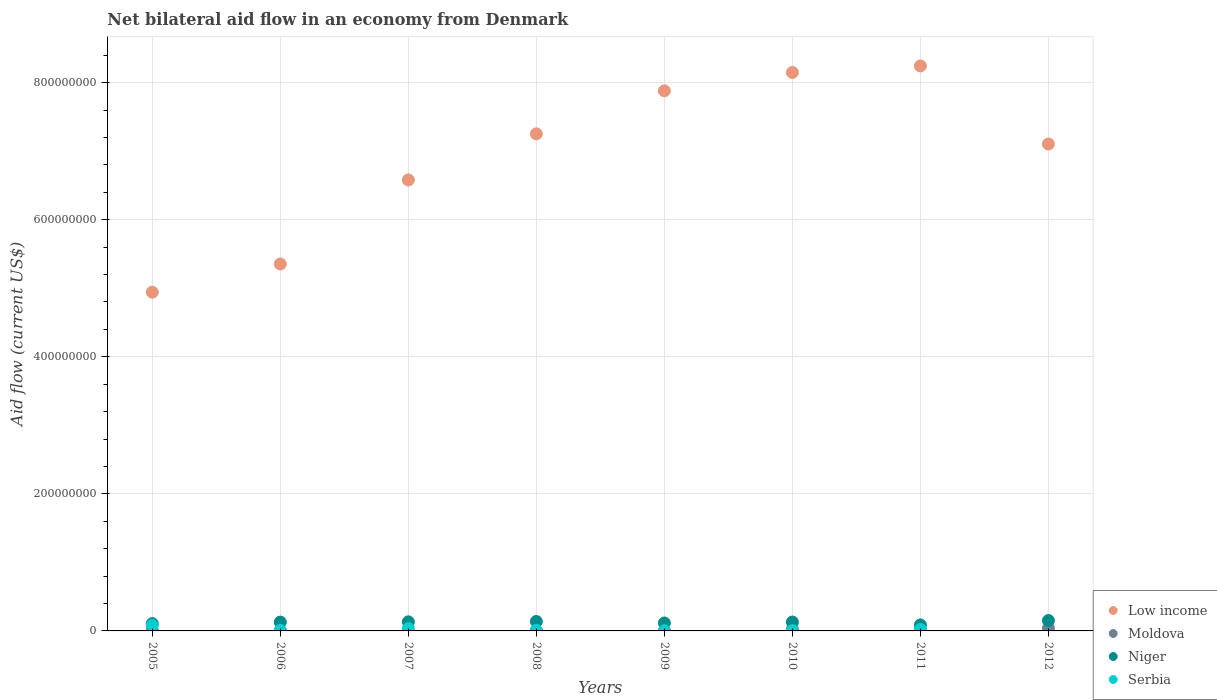How many different coloured dotlines are there?
Ensure brevity in your answer.  4. Is the number of dotlines equal to the number of legend labels?
Keep it short and to the point. No. What is the net bilateral aid flow in Niger in 2006?
Offer a very short reply. 1.29e+07. Across all years, what is the maximum net bilateral aid flow in Niger?
Ensure brevity in your answer.  1.52e+07. Across all years, what is the minimum net bilateral aid flow in Niger?
Make the answer very short. 8.79e+06. What is the total net bilateral aid flow in Niger in the graph?
Give a very brief answer. 9.91e+07. What is the difference between the net bilateral aid flow in Serbia in 2007 and that in 2011?
Make the answer very short. 1.16e+06. What is the difference between the net bilateral aid flow in Serbia in 2006 and the net bilateral aid flow in Niger in 2011?
Your response must be concise. -7.94e+06. What is the average net bilateral aid flow in Niger per year?
Give a very brief answer. 1.24e+07. In the year 2010, what is the difference between the net bilateral aid flow in Niger and net bilateral aid flow in Moldova?
Offer a very short reply. 1.03e+07. What is the ratio of the net bilateral aid flow in Serbia in 2007 to that in 2008?
Your answer should be compact. 3.74. Is the net bilateral aid flow in Low income in 2008 less than that in 2010?
Your response must be concise. Yes. What is the difference between the highest and the second highest net bilateral aid flow in Moldova?
Your response must be concise. 1.28e+06. What is the difference between the highest and the lowest net bilateral aid flow in Serbia?
Offer a terse response. 8.02e+06. In how many years, is the net bilateral aid flow in Serbia greater than the average net bilateral aid flow in Serbia taken over all years?
Make the answer very short. 3. Is the sum of the net bilateral aid flow in Serbia in 2008 and 2011 greater than the maximum net bilateral aid flow in Moldova across all years?
Ensure brevity in your answer.  No. Is it the case that in every year, the sum of the net bilateral aid flow in Moldova and net bilateral aid flow in Serbia  is greater than the net bilateral aid flow in Low income?
Your answer should be compact. No. Does the net bilateral aid flow in Niger monotonically increase over the years?
Your answer should be very brief. No. Is the net bilateral aid flow in Moldova strictly greater than the net bilateral aid flow in Serbia over the years?
Your answer should be compact. No. Is the net bilateral aid flow in Moldova strictly less than the net bilateral aid flow in Low income over the years?
Offer a terse response. Yes. How many years are there in the graph?
Offer a terse response. 8. What is the difference between two consecutive major ticks on the Y-axis?
Your response must be concise. 2.00e+08. Are the values on the major ticks of Y-axis written in scientific E-notation?
Offer a very short reply. No. Does the graph contain any zero values?
Provide a succinct answer. Yes. Where does the legend appear in the graph?
Ensure brevity in your answer.  Bottom right. What is the title of the graph?
Provide a short and direct response. Net bilateral aid flow in an economy from Denmark. What is the label or title of the Y-axis?
Make the answer very short. Aid flow (current US$). What is the Aid flow (current US$) of Low income in 2005?
Keep it short and to the point. 4.94e+08. What is the Aid flow (current US$) in Moldova in 2005?
Offer a very short reply. 9.00e+05. What is the Aid flow (current US$) of Niger in 2005?
Your response must be concise. 1.07e+07. What is the Aid flow (current US$) in Serbia in 2005?
Keep it short and to the point. 8.02e+06. What is the Aid flow (current US$) in Low income in 2006?
Ensure brevity in your answer.  5.35e+08. What is the Aid flow (current US$) in Niger in 2006?
Ensure brevity in your answer.  1.29e+07. What is the Aid flow (current US$) in Serbia in 2006?
Your response must be concise. 8.50e+05. What is the Aid flow (current US$) in Low income in 2007?
Make the answer very short. 6.58e+08. What is the Aid flow (current US$) of Moldova in 2007?
Offer a very short reply. 8.00e+04. What is the Aid flow (current US$) of Niger in 2007?
Your answer should be very brief. 1.33e+07. What is the Aid flow (current US$) of Serbia in 2007?
Your response must be concise. 3.40e+06. What is the Aid flow (current US$) in Low income in 2008?
Provide a short and direct response. 7.25e+08. What is the Aid flow (current US$) of Moldova in 2008?
Make the answer very short. 2.10e+05. What is the Aid flow (current US$) of Niger in 2008?
Keep it short and to the point. 1.38e+07. What is the Aid flow (current US$) in Serbia in 2008?
Offer a terse response. 9.10e+05. What is the Aid flow (current US$) in Low income in 2009?
Make the answer very short. 7.88e+08. What is the Aid flow (current US$) in Moldova in 2009?
Offer a very short reply. 3.40e+05. What is the Aid flow (current US$) in Niger in 2009?
Make the answer very short. 1.16e+07. What is the Aid flow (current US$) of Low income in 2010?
Keep it short and to the point. 8.15e+08. What is the Aid flow (current US$) of Moldova in 2010?
Ensure brevity in your answer.  2.69e+06. What is the Aid flow (current US$) in Niger in 2010?
Give a very brief answer. 1.30e+07. What is the Aid flow (current US$) of Low income in 2011?
Make the answer very short. 8.24e+08. What is the Aid flow (current US$) in Moldova in 2011?
Keep it short and to the point. 1.80e+06. What is the Aid flow (current US$) of Niger in 2011?
Provide a short and direct response. 8.79e+06. What is the Aid flow (current US$) of Serbia in 2011?
Keep it short and to the point. 2.24e+06. What is the Aid flow (current US$) of Low income in 2012?
Keep it short and to the point. 7.11e+08. What is the Aid flow (current US$) of Moldova in 2012?
Provide a short and direct response. 3.97e+06. What is the Aid flow (current US$) of Niger in 2012?
Offer a terse response. 1.52e+07. Across all years, what is the maximum Aid flow (current US$) in Low income?
Your response must be concise. 8.24e+08. Across all years, what is the maximum Aid flow (current US$) in Moldova?
Provide a short and direct response. 3.97e+06. Across all years, what is the maximum Aid flow (current US$) of Niger?
Make the answer very short. 1.52e+07. Across all years, what is the maximum Aid flow (current US$) in Serbia?
Your answer should be compact. 8.02e+06. Across all years, what is the minimum Aid flow (current US$) in Low income?
Provide a succinct answer. 4.94e+08. Across all years, what is the minimum Aid flow (current US$) of Niger?
Your response must be concise. 8.79e+06. Across all years, what is the minimum Aid flow (current US$) of Serbia?
Your answer should be very brief. 0. What is the total Aid flow (current US$) of Low income in the graph?
Make the answer very short. 5.55e+09. What is the total Aid flow (current US$) of Moldova in the graph?
Make the answer very short. 1.04e+07. What is the total Aid flow (current US$) of Niger in the graph?
Your answer should be very brief. 9.91e+07. What is the total Aid flow (current US$) in Serbia in the graph?
Give a very brief answer. 1.61e+07. What is the difference between the Aid flow (current US$) in Low income in 2005 and that in 2006?
Offer a very short reply. -4.12e+07. What is the difference between the Aid flow (current US$) in Moldova in 2005 and that in 2006?
Your answer should be compact. 4.90e+05. What is the difference between the Aid flow (current US$) of Niger in 2005 and that in 2006?
Give a very brief answer. -2.19e+06. What is the difference between the Aid flow (current US$) in Serbia in 2005 and that in 2006?
Give a very brief answer. 7.17e+06. What is the difference between the Aid flow (current US$) of Low income in 2005 and that in 2007?
Offer a very short reply. -1.64e+08. What is the difference between the Aid flow (current US$) in Moldova in 2005 and that in 2007?
Provide a succinct answer. 8.20e+05. What is the difference between the Aid flow (current US$) in Niger in 2005 and that in 2007?
Offer a very short reply. -2.59e+06. What is the difference between the Aid flow (current US$) of Serbia in 2005 and that in 2007?
Provide a succinct answer. 4.62e+06. What is the difference between the Aid flow (current US$) of Low income in 2005 and that in 2008?
Provide a short and direct response. -2.31e+08. What is the difference between the Aid flow (current US$) in Moldova in 2005 and that in 2008?
Make the answer very short. 6.90e+05. What is the difference between the Aid flow (current US$) in Niger in 2005 and that in 2008?
Offer a terse response. -3.12e+06. What is the difference between the Aid flow (current US$) of Serbia in 2005 and that in 2008?
Ensure brevity in your answer.  7.11e+06. What is the difference between the Aid flow (current US$) of Low income in 2005 and that in 2009?
Ensure brevity in your answer.  -2.94e+08. What is the difference between the Aid flow (current US$) in Moldova in 2005 and that in 2009?
Provide a short and direct response. 5.60e+05. What is the difference between the Aid flow (current US$) in Niger in 2005 and that in 2009?
Offer a terse response. -9.20e+05. What is the difference between the Aid flow (current US$) in Serbia in 2005 and that in 2009?
Your response must be concise. 7.71e+06. What is the difference between the Aid flow (current US$) of Low income in 2005 and that in 2010?
Give a very brief answer. -3.21e+08. What is the difference between the Aid flow (current US$) of Moldova in 2005 and that in 2010?
Your response must be concise. -1.79e+06. What is the difference between the Aid flow (current US$) of Niger in 2005 and that in 2010?
Provide a succinct answer. -2.29e+06. What is the difference between the Aid flow (current US$) in Serbia in 2005 and that in 2010?
Make the answer very short. 7.65e+06. What is the difference between the Aid flow (current US$) of Low income in 2005 and that in 2011?
Keep it short and to the point. -3.30e+08. What is the difference between the Aid flow (current US$) of Moldova in 2005 and that in 2011?
Keep it short and to the point. -9.00e+05. What is the difference between the Aid flow (current US$) of Niger in 2005 and that in 2011?
Your answer should be compact. 1.88e+06. What is the difference between the Aid flow (current US$) in Serbia in 2005 and that in 2011?
Your answer should be very brief. 5.78e+06. What is the difference between the Aid flow (current US$) of Low income in 2005 and that in 2012?
Your answer should be compact. -2.16e+08. What is the difference between the Aid flow (current US$) of Moldova in 2005 and that in 2012?
Give a very brief answer. -3.07e+06. What is the difference between the Aid flow (current US$) of Niger in 2005 and that in 2012?
Keep it short and to the point. -4.51e+06. What is the difference between the Aid flow (current US$) of Low income in 2006 and that in 2007?
Give a very brief answer. -1.23e+08. What is the difference between the Aid flow (current US$) of Niger in 2006 and that in 2007?
Ensure brevity in your answer.  -4.00e+05. What is the difference between the Aid flow (current US$) of Serbia in 2006 and that in 2007?
Offer a very short reply. -2.55e+06. What is the difference between the Aid flow (current US$) of Low income in 2006 and that in 2008?
Offer a very short reply. -1.90e+08. What is the difference between the Aid flow (current US$) of Moldova in 2006 and that in 2008?
Your answer should be very brief. 2.00e+05. What is the difference between the Aid flow (current US$) in Niger in 2006 and that in 2008?
Provide a succinct answer. -9.30e+05. What is the difference between the Aid flow (current US$) in Serbia in 2006 and that in 2008?
Ensure brevity in your answer.  -6.00e+04. What is the difference between the Aid flow (current US$) in Low income in 2006 and that in 2009?
Provide a succinct answer. -2.53e+08. What is the difference between the Aid flow (current US$) in Moldova in 2006 and that in 2009?
Provide a succinct answer. 7.00e+04. What is the difference between the Aid flow (current US$) of Niger in 2006 and that in 2009?
Provide a succinct answer. 1.27e+06. What is the difference between the Aid flow (current US$) in Serbia in 2006 and that in 2009?
Your answer should be compact. 5.40e+05. What is the difference between the Aid flow (current US$) in Low income in 2006 and that in 2010?
Keep it short and to the point. -2.80e+08. What is the difference between the Aid flow (current US$) in Moldova in 2006 and that in 2010?
Give a very brief answer. -2.28e+06. What is the difference between the Aid flow (current US$) in Serbia in 2006 and that in 2010?
Your answer should be compact. 4.80e+05. What is the difference between the Aid flow (current US$) of Low income in 2006 and that in 2011?
Offer a very short reply. -2.89e+08. What is the difference between the Aid flow (current US$) of Moldova in 2006 and that in 2011?
Keep it short and to the point. -1.39e+06. What is the difference between the Aid flow (current US$) in Niger in 2006 and that in 2011?
Make the answer very short. 4.07e+06. What is the difference between the Aid flow (current US$) of Serbia in 2006 and that in 2011?
Offer a terse response. -1.39e+06. What is the difference between the Aid flow (current US$) of Low income in 2006 and that in 2012?
Provide a short and direct response. -1.75e+08. What is the difference between the Aid flow (current US$) of Moldova in 2006 and that in 2012?
Offer a very short reply. -3.56e+06. What is the difference between the Aid flow (current US$) in Niger in 2006 and that in 2012?
Keep it short and to the point. -2.32e+06. What is the difference between the Aid flow (current US$) of Low income in 2007 and that in 2008?
Offer a terse response. -6.72e+07. What is the difference between the Aid flow (current US$) of Niger in 2007 and that in 2008?
Give a very brief answer. -5.30e+05. What is the difference between the Aid flow (current US$) in Serbia in 2007 and that in 2008?
Give a very brief answer. 2.49e+06. What is the difference between the Aid flow (current US$) of Low income in 2007 and that in 2009?
Ensure brevity in your answer.  -1.30e+08. What is the difference between the Aid flow (current US$) of Moldova in 2007 and that in 2009?
Give a very brief answer. -2.60e+05. What is the difference between the Aid flow (current US$) in Niger in 2007 and that in 2009?
Keep it short and to the point. 1.67e+06. What is the difference between the Aid flow (current US$) in Serbia in 2007 and that in 2009?
Provide a succinct answer. 3.09e+06. What is the difference between the Aid flow (current US$) of Low income in 2007 and that in 2010?
Your answer should be very brief. -1.57e+08. What is the difference between the Aid flow (current US$) of Moldova in 2007 and that in 2010?
Keep it short and to the point. -2.61e+06. What is the difference between the Aid flow (current US$) in Niger in 2007 and that in 2010?
Your answer should be very brief. 3.00e+05. What is the difference between the Aid flow (current US$) in Serbia in 2007 and that in 2010?
Offer a very short reply. 3.03e+06. What is the difference between the Aid flow (current US$) of Low income in 2007 and that in 2011?
Your answer should be compact. -1.66e+08. What is the difference between the Aid flow (current US$) of Moldova in 2007 and that in 2011?
Ensure brevity in your answer.  -1.72e+06. What is the difference between the Aid flow (current US$) of Niger in 2007 and that in 2011?
Give a very brief answer. 4.47e+06. What is the difference between the Aid flow (current US$) in Serbia in 2007 and that in 2011?
Your answer should be very brief. 1.16e+06. What is the difference between the Aid flow (current US$) in Low income in 2007 and that in 2012?
Your answer should be very brief. -5.24e+07. What is the difference between the Aid flow (current US$) of Moldova in 2007 and that in 2012?
Ensure brevity in your answer.  -3.89e+06. What is the difference between the Aid flow (current US$) in Niger in 2007 and that in 2012?
Give a very brief answer. -1.92e+06. What is the difference between the Aid flow (current US$) of Low income in 2008 and that in 2009?
Give a very brief answer. -6.28e+07. What is the difference between the Aid flow (current US$) in Niger in 2008 and that in 2009?
Give a very brief answer. 2.20e+06. What is the difference between the Aid flow (current US$) in Serbia in 2008 and that in 2009?
Give a very brief answer. 6.00e+05. What is the difference between the Aid flow (current US$) of Low income in 2008 and that in 2010?
Your answer should be compact. -8.96e+07. What is the difference between the Aid flow (current US$) of Moldova in 2008 and that in 2010?
Offer a very short reply. -2.48e+06. What is the difference between the Aid flow (current US$) of Niger in 2008 and that in 2010?
Offer a very short reply. 8.30e+05. What is the difference between the Aid flow (current US$) in Serbia in 2008 and that in 2010?
Offer a terse response. 5.40e+05. What is the difference between the Aid flow (current US$) in Low income in 2008 and that in 2011?
Your answer should be compact. -9.91e+07. What is the difference between the Aid flow (current US$) in Moldova in 2008 and that in 2011?
Keep it short and to the point. -1.59e+06. What is the difference between the Aid flow (current US$) in Niger in 2008 and that in 2011?
Make the answer very short. 5.00e+06. What is the difference between the Aid flow (current US$) of Serbia in 2008 and that in 2011?
Offer a terse response. -1.33e+06. What is the difference between the Aid flow (current US$) in Low income in 2008 and that in 2012?
Provide a short and direct response. 1.49e+07. What is the difference between the Aid flow (current US$) of Moldova in 2008 and that in 2012?
Your response must be concise. -3.76e+06. What is the difference between the Aid flow (current US$) in Niger in 2008 and that in 2012?
Provide a succinct answer. -1.39e+06. What is the difference between the Aid flow (current US$) of Low income in 2009 and that in 2010?
Ensure brevity in your answer.  -2.68e+07. What is the difference between the Aid flow (current US$) of Moldova in 2009 and that in 2010?
Make the answer very short. -2.35e+06. What is the difference between the Aid flow (current US$) in Niger in 2009 and that in 2010?
Your response must be concise. -1.37e+06. What is the difference between the Aid flow (current US$) of Low income in 2009 and that in 2011?
Offer a very short reply. -3.63e+07. What is the difference between the Aid flow (current US$) of Moldova in 2009 and that in 2011?
Give a very brief answer. -1.46e+06. What is the difference between the Aid flow (current US$) of Niger in 2009 and that in 2011?
Provide a succinct answer. 2.80e+06. What is the difference between the Aid flow (current US$) in Serbia in 2009 and that in 2011?
Keep it short and to the point. -1.93e+06. What is the difference between the Aid flow (current US$) of Low income in 2009 and that in 2012?
Make the answer very short. 7.77e+07. What is the difference between the Aid flow (current US$) in Moldova in 2009 and that in 2012?
Your answer should be very brief. -3.63e+06. What is the difference between the Aid flow (current US$) of Niger in 2009 and that in 2012?
Keep it short and to the point. -3.59e+06. What is the difference between the Aid flow (current US$) of Low income in 2010 and that in 2011?
Ensure brevity in your answer.  -9.54e+06. What is the difference between the Aid flow (current US$) of Moldova in 2010 and that in 2011?
Your answer should be compact. 8.90e+05. What is the difference between the Aid flow (current US$) in Niger in 2010 and that in 2011?
Ensure brevity in your answer.  4.17e+06. What is the difference between the Aid flow (current US$) in Serbia in 2010 and that in 2011?
Make the answer very short. -1.87e+06. What is the difference between the Aid flow (current US$) of Low income in 2010 and that in 2012?
Make the answer very short. 1.04e+08. What is the difference between the Aid flow (current US$) of Moldova in 2010 and that in 2012?
Your answer should be compact. -1.28e+06. What is the difference between the Aid flow (current US$) in Niger in 2010 and that in 2012?
Offer a very short reply. -2.22e+06. What is the difference between the Aid flow (current US$) in Low income in 2011 and that in 2012?
Provide a succinct answer. 1.14e+08. What is the difference between the Aid flow (current US$) of Moldova in 2011 and that in 2012?
Offer a very short reply. -2.17e+06. What is the difference between the Aid flow (current US$) in Niger in 2011 and that in 2012?
Your answer should be compact. -6.39e+06. What is the difference between the Aid flow (current US$) of Low income in 2005 and the Aid flow (current US$) of Moldova in 2006?
Make the answer very short. 4.94e+08. What is the difference between the Aid flow (current US$) of Low income in 2005 and the Aid flow (current US$) of Niger in 2006?
Ensure brevity in your answer.  4.81e+08. What is the difference between the Aid flow (current US$) in Low income in 2005 and the Aid flow (current US$) in Serbia in 2006?
Offer a terse response. 4.93e+08. What is the difference between the Aid flow (current US$) of Moldova in 2005 and the Aid flow (current US$) of Niger in 2006?
Keep it short and to the point. -1.20e+07. What is the difference between the Aid flow (current US$) of Moldova in 2005 and the Aid flow (current US$) of Serbia in 2006?
Keep it short and to the point. 5.00e+04. What is the difference between the Aid flow (current US$) in Niger in 2005 and the Aid flow (current US$) in Serbia in 2006?
Your answer should be compact. 9.82e+06. What is the difference between the Aid flow (current US$) of Low income in 2005 and the Aid flow (current US$) of Moldova in 2007?
Offer a very short reply. 4.94e+08. What is the difference between the Aid flow (current US$) of Low income in 2005 and the Aid flow (current US$) of Niger in 2007?
Provide a succinct answer. 4.81e+08. What is the difference between the Aid flow (current US$) in Low income in 2005 and the Aid flow (current US$) in Serbia in 2007?
Your answer should be compact. 4.91e+08. What is the difference between the Aid flow (current US$) of Moldova in 2005 and the Aid flow (current US$) of Niger in 2007?
Your answer should be compact. -1.24e+07. What is the difference between the Aid flow (current US$) in Moldova in 2005 and the Aid flow (current US$) in Serbia in 2007?
Provide a short and direct response. -2.50e+06. What is the difference between the Aid flow (current US$) of Niger in 2005 and the Aid flow (current US$) of Serbia in 2007?
Your response must be concise. 7.27e+06. What is the difference between the Aid flow (current US$) in Low income in 2005 and the Aid flow (current US$) in Moldova in 2008?
Provide a succinct answer. 4.94e+08. What is the difference between the Aid flow (current US$) in Low income in 2005 and the Aid flow (current US$) in Niger in 2008?
Make the answer very short. 4.80e+08. What is the difference between the Aid flow (current US$) of Low income in 2005 and the Aid flow (current US$) of Serbia in 2008?
Make the answer very short. 4.93e+08. What is the difference between the Aid flow (current US$) in Moldova in 2005 and the Aid flow (current US$) in Niger in 2008?
Your answer should be compact. -1.29e+07. What is the difference between the Aid flow (current US$) in Moldova in 2005 and the Aid flow (current US$) in Serbia in 2008?
Keep it short and to the point. -10000. What is the difference between the Aid flow (current US$) in Niger in 2005 and the Aid flow (current US$) in Serbia in 2008?
Your answer should be compact. 9.76e+06. What is the difference between the Aid flow (current US$) in Low income in 2005 and the Aid flow (current US$) in Moldova in 2009?
Your answer should be very brief. 4.94e+08. What is the difference between the Aid flow (current US$) in Low income in 2005 and the Aid flow (current US$) in Niger in 2009?
Your answer should be very brief. 4.83e+08. What is the difference between the Aid flow (current US$) in Low income in 2005 and the Aid flow (current US$) in Serbia in 2009?
Provide a succinct answer. 4.94e+08. What is the difference between the Aid flow (current US$) in Moldova in 2005 and the Aid flow (current US$) in Niger in 2009?
Provide a succinct answer. -1.07e+07. What is the difference between the Aid flow (current US$) of Moldova in 2005 and the Aid flow (current US$) of Serbia in 2009?
Keep it short and to the point. 5.90e+05. What is the difference between the Aid flow (current US$) of Niger in 2005 and the Aid flow (current US$) of Serbia in 2009?
Give a very brief answer. 1.04e+07. What is the difference between the Aid flow (current US$) in Low income in 2005 and the Aid flow (current US$) in Moldova in 2010?
Your response must be concise. 4.92e+08. What is the difference between the Aid flow (current US$) of Low income in 2005 and the Aid flow (current US$) of Niger in 2010?
Keep it short and to the point. 4.81e+08. What is the difference between the Aid flow (current US$) in Low income in 2005 and the Aid flow (current US$) in Serbia in 2010?
Your answer should be very brief. 4.94e+08. What is the difference between the Aid flow (current US$) of Moldova in 2005 and the Aid flow (current US$) of Niger in 2010?
Offer a terse response. -1.21e+07. What is the difference between the Aid flow (current US$) in Moldova in 2005 and the Aid flow (current US$) in Serbia in 2010?
Give a very brief answer. 5.30e+05. What is the difference between the Aid flow (current US$) in Niger in 2005 and the Aid flow (current US$) in Serbia in 2010?
Your response must be concise. 1.03e+07. What is the difference between the Aid flow (current US$) of Low income in 2005 and the Aid flow (current US$) of Moldova in 2011?
Offer a very short reply. 4.92e+08. What is the difference between the Aid flow (current US$) in Low income in 2005 and the Aid flow (current US$) in Niger in 2011?
Offer a very short reply. 4.86e+08. What is the difference between the Aid flow (current US$) in Low income in 2005 and the Aid flow (current US$) in Serbia in 2011?
Your answer should be compact. 4.92e+08. What is the difference between the Aid flow (current US$) in Moldova in 2005 and the Aid flow (current US$) in Niger in 2011?
Offer a terse response. -7.89e+06. What is the difference between the Aid flow (current US$) in Moldova in 2005 and the Aid flow (current US$) in Serbia in 2011?
Your answer should be compact. -1.34e+06. What is the difference between the Aid flow (current US$) in Niger in 2005 and the Aid flow (current US$) in Serbia in 2011?
Provide a short and direct response. 8.43e+06. What is the difference between the Aid flow (current US$) in Low income in 2005 and the Aid flow (current US$) in Moldova in 2012?
Your response must be concise. 4.90e+08. What is the difference between the Aid flow (current US$) of Low income in 2005 and the Aid flow (current US$) of Niger in 2012?
Provide a short and direct response. 4.79e+08. What is the difference between the Aid flow (current US$) of Moldova in 2005 and the Aid flow (current US$) of Niger in 2012?
Your answer should be very brief. -1.43e+07. What is the difference between the Aid flow (current US$) of Low income in 2006 and the Aid flow (current US$) of Moldova in 2007?
Your answer should be very brief. 5.35e+08. What is the difference between the Aid flow (current US$) of Low income in 2006 and the Aid flow (current US$) of Niger in 2007?
Your response must be concise. 5.22e+08. What is the difference between the Aid flow (current US$) of Low income in 2006 and the Aid flow (current US$) of Serbia in 2007?
Your answer should be compact. 5.32e+08. What is the difference between the Aid flow (current US$) of Moldova in 2006 and the Aid flow (current US$) of Niger in 2007?
Offer a very short reply. -1.28e+07. What is the difference between the Aid flow (current US$) of Moldova in 2006 and the Aid flow (current US$) of Serbia in 2007?
Offer a terse response. -2.99e+06. What is the difference between the Aid flow (current US$) of Niger in 2006 and the Aid flow (current US$) of Serbia in 2007?
Provide a short and direct response. 9.46e+06. What is the difference between the Aid flow (current US$) in Low income in 2006 and the Aid flow (current US$) in Moldova in 2008?
Give a very brief answer. 5.35e+08. What is the difference between the Aid flow (current US$) of Low income in 2006 and the Aid flow (current US$) of Niger in 2008?
Ensure brevity in your answer.  5.22e+08. What is the difference between the Aid flow (current US$) in Low income in 2006 and the Aid flow (current US$) in Serbia in 2008?
Give a very brief answer. 5.35e+08. What is the difference between the Aid flow (current US$) of Moldova in 2006 and the Aid flow (current US$) of Niger in 2008?
Your answer should be very brief. -1.34e+07. What is the difference between the Aid flow (current US$) in Moldova in 2006 and the Aid flow (current US$) in Serbia in 2008?
Make the answer very short. -5.00e+05. What is the difference between the Aid flow (current US$) of Niger in 2006 and the Aid flow (current US$) of Serbia in 2008?
Your response must be concise. 1.20e+07. What is the difference between the Aid flow (current US$) of Low income in 2006 and the Aid flow (current US$) of Moldova in 2009?
Your response must be concise. 5.35e+08. What is the difference between the Aid flow (current US$) in Low income in 2006 and the Aid flow (current US$) in Niger in 2009?
Your answer should be very brief. 5.24e+08. What is the difference between the Aid flow (current US$) in Low income in 2006 and the Aid flow (current US$) in Serbia in 2009?
Offer a terse response. 5.35e+08. What is the difference between the Aid flow (current US$) of Moldova in 2006 and the Aid flow (current US$) of Niger in 2009?
Provide a short and direct response. -1.12e+07. What is the difference between the Aid flow (current US$) of Niger in 2006 and the Aid flow (current US$) of Serbia in 2009?
Offer a terse response. 1.26e+07. What is the difference between the Aid flow (current US$) in Low income in 2006 and the Aid flow (current US$) in Moldova in 2010?
Provide a succinct answer. 5.33e+08. What is the difference between the Aid flow (current US$) in Low income in 2006 and the Aid flow (current US$) in Niger in 2010?
Offer a very short reply. 5.22e+08. What is the difference between the Aid flow (current US$) in Low income in 2006 and the Aid flow (current US$) in Serbia in 2010?
Provide a short and direct response. 5.35e+08. What is the difference between the Aid flow (current US$) in Moldova in 2006 and the Aid flow (current US$) in Niger in 2010?
Ensure brevity in your answer.  -1.26e+07. What is the difference between the Aid flow (current US$) of Niger in 2006 and the Aid flow (current US$) of Serbia in 2010?
Ensure brevity in your answer.  1.25e+07. What is the difference between the Aid flow (current US$) of Low income in 2006 and the Aid flow (current US$) of Moldova in 2011?
Your answer should be compact. 5.34e+08. What is the difference between the Aid flow (current US$) of Low income in 2006 and the Aid flow (current US$) of Niger in 2011?
Give a very brief answer. 5.27e+08. What is the difference between the Aid flow (current US$) of Low income in 2006 and the Aid flow (current US$) of Serbia in 2011?
Give a very brief answer. 5.33e+08. What is the difference between the Aid flow (current US$) of Moldova in 2006 and the Aid flow (current US$) of Niger in 2011?
Offer a terse response. -8.38e+06. What is the difference between the Aid flow (current US$) of Moldova in 2006 and the Aid flow (current US$) of Serbia in 2011?
Ensure brevity in your answer.  -1.83e+06. What is the difference between the Aid flow (current US$) in Niger in 2006 and the Aid flow (current US$) in Serbia in 2011?
Provide a succinct answer. 1.06e+07. What is the difference between the Aid flow (current US$) of Low income in 2006 and the Aid flow (current US$) of Moldova in 2012?
Provide a short and direct response. 5.31e+08. What is the difference between the Aid flow (current US$) of Low income in 2006 and the Aid flow (current US$) of Niger in 2012?
Give a very brief answer. 5.20e+08. What is the difference between the Aid flow (current US$) of Moldova in 2006 and the Aid flow (current US$) of Niger in 2012?
Your answer should be very brief. -1.48e+07. What is the difference between the Aid flow (current US$) in Low income in 2007 and the Aid flow (current US$) in Moldova in 2008?
Offer a very short reply. 6.58e+08. What is the difference between the Aid flow (current US$) in Low income in 2007 and the Aid flow (current US$) in Niger in 2008?
Offer a very short reply. 6.44e+08. What is the difference between the Aid flow (current US$) in Low income in 2007 and the Aid flow (current US$) in Serbia in 2008?
Your answer should be compact. 6.57e+08. What is the difference between the Aid flow (current US$) of Moldova in 2007 and the Aid flow (current US$) of Niger in 2008?
Provide a short and direct response. -1.37e+07. What is the difference between the Aid flow (current US$) of Moldova in 2007 and the Aid flow (current US$) of Serbia in 2008?
Provide a short and direct response. -8.30e+05. What is the difference between the Aid flow (current US$) of Niger in 2007 and the Aid flow (current US$) of Serbia in 2008?
Make the answer very short. 1.24e+07. What is the difference between the Aid flow (current US$) of Low income in 2007 and the Aid flow (current US$) of Moldova in 2009?
Give a very brief answer. 6.58e+08. What is the difference between the Aid flow (current US$) of Low income in 2007 and the Aid flow (current US$) of Niger in 2009?
Provide a short and direct response. 6.47e+08. What is the difference between the Aid flow (current US$) in Low income in 2007 and the Aid flow (current US$) in Serbia in 2009?
Provide a short and direct response. 6.58e+08. What is the difference between the Aid flow (current US$) in Moldova in 2007 and the Aid flow (current US$) in Niger in 2009?
Provide a succinct answer. -1.15e+07. What is the difference between the Aid flow (current US$) in Moldova in 2007 and the Aid flow (current US$) in Serbia in 2009?
Your response must be concise. -2.30e+05. What is the difference between the Aid flow (current US$) of Niger in 2007 and the Aid flow (current US$) of Serbia in 2009?
Make the answer very short. 1.30e+07. What is the difference between the Aid flow (current US$) in Low income in 2007 and the Aid flow (current US$) in Moldova in 2010?
Offer a terse response. 6.55e+08. What is the difference between the Aid flow (current US$) in Low income in 2007 and the Aid flow (current US$) in Niger in 2010?
Your answer should be very brief. 6.45e+08. What is the difference between the Aid flow (current US$) of Low income in 2007 and the Aid flow (current US$) of Serbia in 2010?
Offer a very short reply. 6.58e+08. What is the difference between the Aid flow (current US$) in Moldova in 2007 and the Aid flow (current US$) in Niger in 2010?
Make the answer very short. -1.29e+07. What is the difference between the Aid flow (current US$) in Niger in 2007 and the Aid flow (current US$) in Serbia in 2010?
Your answer should be very brief. 1.29e+07. What is the difference between the Aid flow (current US$) in Low income in 2007 and the Aid flow (current US$) in Moldova in 2011?
Ensure brevity in your answer.  6.56e+08. What is the difference between the Aid flow (current US$) in Low income in 2007 and the Aid flow (current US$) in Niger in 2011?
Your response must be concise. 6.49e+08. What is the difference between the Aid flow (current US$) of Low income in 2007 and the Aid flow (current US$) of Serbia in 2011?
Provide a short and direct response. 6.56e+08. What is the difference between the Aid flow (current US$) of Moldova in 2007 and the Aid flow (current US$) of Niger in 2011?
Your answer should be compact. -8.71e+06. What is the difference between the Aid flow (current US$) of Moldova in 2007 and the Aid flow (current US$) of Serbia in 2011?
Ensure brevity in your answer.  -2.16e+06. What is the difference between the Aid flow (current US$) in Niger in 2007 and the Aid flow (current US$) in Serbia in 2011?
Ensure brevity in your answer.  1.10e+07. What is the difference between the Aid flow (current US$) of Low income in 2007 and the Aid flow (current US$) of Moldova in 2012?
Offer a terse response. 6.54e+08. What is the difference between the Aid flow (current US$) of Low income in 2007 and the Aid flow (current US$) of Niger in 2012?
Your answer should be very brief. 6.43e+08. What is the difference between the Aid flow (current US$) of Moldova in 2007 and the Aid flow (current US$) of Niger in 2012?
Offer a very short reply. -1.51e+07. What is the difference between the Aid flow (current US$) of Low income in 2008 and the Aid flow (current US$) of Moldova in 2009?
Your answer should be very brief. 7.25e+08. What is the difference between the Aid flow (current US$) of Low income in 2008 and the Aid flow (current US$) of Niger in 2009?
Your answer should be compact. 7.14e+08. What is the difference between the Aid flow (current US$) in Low income in 2008 and the Aid flow (current US$) in Serbia in 2009?
Offer a terse response. 7.25e+08. What is the difference between the Aid flow (current US$) of Moldova in 2008 and the Aid flow (current US$) of Niger in 2009?
Provide a succinct answer. -1.14e+07. What is the difference between the Aid flow (current US$) in Niger in 2008 and the Aid flow (current US$) in Serbia in 2009?
Provide a succinct answer. 1.35e+07. What is the difference between the Aid flow (current US$) in Low income in 2008 and the Aid flow (current US$) in Moldova in 2010?
Make the answer very short. 7.23e+08. What is the difference between the Aid flow (current US$) in Low income in 2008 and the Aid flow (current US$) in Niger in 2010?
Provide a short and direct response. 7.12e+08. What is the difference between the Aid flow (current US$) of Low income in 2008 and the Aid flow (current US$) of Serbia in 2010?
Give a very brief answer. 7.25e+08. What is the difference between the Aid flow (current US$) of Moldova in 2008 and the Aid flow (current US$) of Niger in 2010?
Offer a terse response. -1.28e+07. What is the difference between the Aid flow (current US$) of Niger in 2008 and the Aid flow (current US$) of Serbia in 2010?
Offer a terse response. 1.34e+07. What is the difference between the Aid flow (current US$) in Low income in 2008 and the Aid flow (current US$) in Moldova in 2011?
Your answer should be very brief. 7.24e+08. What is the difference between the Aid flow (current US$) in Low income in 2008 and the Aid flow (current US$) in Niger in 2011?
Offer a terse response. 7.17e+08. What is the difference between the Aid flow (current US$) of Low income in 2008 and the Aid flow (current US$) of Serbia in 2011?
Keep it short and to the point. 7.23e+08. What is the difference between the Aid flow (current US$) in Moldova in 2008 and the Aid flow (current US$) in Niger in 2011?
Offer a terse response. -8.58e+06. What is the difference between the Aid flow (current US$) of Moldova in 2008 and the Aid flow (current US$) of Serbia in 2011?
Make the answer very short. -2.03e+06. What is the difference between the Aid flow (current US$) in Niger in 2008 and the Aid flow (current US$) in Serbia in 2011?
Your response must be concise. 1.16e+07. What is the difference between the Aid flow (current US$) of Low income in 2008 and the Aid flow (current US$) of Moldova in 2012?
Ensure brevity in your answer.  7.21e+08. What is the difference between the Aid flow (current US$) of Low income in 2008 and the Aid flow (current US$) of Niger in 2012?
Offer a very short reply. 7.10e+08. What is the difference between the Aid flow (current US$) of Moldova in 2008 and the Aid flow (current US$) of Niger in 2012?
Make the answer very short. -1.50e+07. What is the difference between the Aid flow (current US$) in Low income in 2009 and the Aid flow (current US$) in Moldova in 2010?
Give a very brief answer. 7.86e+08. What is the difference between the Aid flow (current US$) in Low income in 2009 and the Aid flow (current US$) in Niger in 2010?
Your answer should be very brief. 7.75e+08. What is the difference between the Aid flow (current US$) of Low income in 2009 and the Aid flow (current US$) of Serbia in 2010?
Offer a terse response. 7.88e+08. What is the difference between the Aid flow (current US$) of Moldova in 2009 and the Aid flow (current US$) of Niger in 2010?
Make the answer very short. -1.26e+07. What is the difference between the Aid flow (current US$) in Moldova in 2009 and the Aid flow (current US$) in Serbia in 2010?
Give a very brief answer. -3.00e+04. What is the difference between the Aid flow (current US$) of Niger in 2009 and the Aid flow (current US$) of Serbia in 2010?
Your response must be concise. 1.12e+07. What is the difference between the Aid flow (current US$) of Low income in 2009 and the Aid flow (current US$) of Moldova in 2011?
Your answer should be very brief. 7.86e+08. What is the difference between the Aid flow (current US$) of Low income in 2009 and the Aid flow (current US$) of Niger in 2011?
Ensure brevity in your answer.  7.79e+08. What is the difference between the Aid flow (current US$) in Low income in 2009 and the Aid flow (current US$) in Serbia in 2011?
Keep it short and to the point. 7.86e+08. What is the difference between the Aid flow (current US$) of Moldova in 2009 and the Aid flow (current US$) of Niger in 2011?
Offer a terse response. -8.45e+06. What is the difference between the Aid flow (current US$) of Moldova in 2009 and the Aid flow (current US$) of Serbia in 2011?
Offer a terse response. -1.90e+06. What is the difference between the Aid flow (current US$) in Niger in 2009 and the Aid flow (current US$) in Serbia in 2011?
Your answer should be compact. 9.35e+06. What is the difference between the Aid flow (current US$) of Low income in 2009 and the Aid flow (current US$) of Moldova in 2012?
Provide a short and direct response. 7.84e+08. What is the difference between the Aid flow (current US$) of Low income in 2009 and the Aid flow (current US$) of Niger in 2012?
Your answer should be very brief. 7.73e+08. What is the difference between the Aid flow (current US$) in Moldova in 2009 and the Aid flow (current US$) in Niger in 2012?
Provide a short and direct response. -1.48e+07. What is the difference between the Aid flow (current US$) of Low income in 2010 and the Aid flow (current US$) of Moldova in 2011?
Provide a succinct answer. 8.13e+08. What is the difference between the Aid flow (current US$) of Low income in 2010 and the Aid flow (current US$) of Niger in 2011?
Make the answer very short. 8.06e+08. What is the difference between the Aid flow (current US$) of Low income in 2010 and the Aid flow (current US$) of Serbia in 2011?
Provide a succinct answer. 8.13e+08. What is the difference between the Aid flow (current US$) in Moldova in 2010 and the Aid flow (current US$) in Niger in 2011?
Your response must be concise. -6.10e+06. What is the difference between the Aid flow (current US$) of Moldova in 2010 and the Aid flow (current US$) of Serbia in 2011?
Make the answer very short. 4.50e+05. What is the difference between the Aid flow (current US$) of Niger in 2010 and the Aid flow (current US$) of Serbia in 2011?
Your answer should be very brief. 1.07e+07. What is the difference between the Aid flow (current US$) of Low income in 2010 and the Aid flow (current US$) of Moldova in 2012?
Your answer should be compact. 8.11e+08. What is the difference between the Aid flow (current US$) in Low income in 2010 and the Aid flow (current US$) in Niger in 2012?
Keep it short and to the point. 8.00e+08. What is the difference between the Aid flow (current US$) of Moldova in 2010 and the Aid flow (current US$) of Niger in 2012?
Keep it short and to the point. -1.25e+07. What is the difference between the Aid flow (current US$) in Low income in 2011 and the Aid flow (current US$) in Moldova in 2012?
Offer a very short reply. 8.21e+08. What is the difference between the Aid flow (current US$) of Low income in 2011 and the Aid flow (current US$) of Niger in 2012?
Make the answer very short. 8.09e+08. What is the difference between the Aid flow (current US$) in Moldova in 2011 and the Aid flow (current US$) in Niger in 2012?
Provide a succinct answer. -1.34e+07. What is the average Aid flow (current US$) of Low income per year?
Your response must be concise. 6.94e+08. What is the average Aid flow (current US$) of Moldova per year?
Give a very brief answer. 1.30e+06. What is the average Aid flow (current US$) of Niger per year?
Ensure brevity in your answer.  1.24e+07. What is the average Aid flow (current US$) in Serbia per year?
Your answer should be very brief. 2.01e+06. In the year 2005, what is the difference between the Aid flow (current US$) of Low income and Aid flow (current US$) of Moldova?
Keep it short and to the point. 4.93e+08. In the year 2005, what is the difference between the Aid flow (current US$) of Low income and Aid flow (current US$) of Niger?
Your answer should be compact. 4.84e+08. In the year 2005, what is the difference between the Aid flow (current US$) in Low income and Aid flow (current US$) in Serbia?
Give a very brief answer. 4.86e+08. In the year 2005, what is the difference between the Aid flow (current US$) of Moldova and Aid flow (current US$) of Niger?
Offer a terse response. -9.77e+06. In the year 2005, what is the difference between the Aid flow (current US$) of Moldova and Aid flow (current US$) of Serbia?
Ensure brevity in your answer.  -7.12e+06. In the year 2005, what is the difference between the Aid flow (current US$) in Niger and Aid flow (current US$) in Serbia?
Ensure brevity in your answer.  2.65e+06. In the year 2006, what is the difference between the Aid flow (current US$) of Low income and Aid flow (current US$) of Moldova?
Offer a very short reply. 5.35e+08. In the year 2006, what is the difference between the Aid flow (current US$) of Low income and Aid flow (current US$) of Niger?
Provide a succinct answer. 5.23e+08. In the year 2006, what is the difference between the Aid flow (current US$) of Low income and Aid flow (current US$) of Serbia?
Provide a short and direct response. 5.35e+08. In the year 2006, what is the difference between the Aid flow (current US$) of Moldova and Aid flow (current US$) of Niger?
Ensure brevity in your answer.  -1.24e+07. In the year 2006, what is the difference between the Aid flow (current US$) of Moldova and Aid flow (current US$) of Serbia?
Provide a short and direct response. -4.40e+05. In the year 2006, what is the difference between the Aid flow (current US$) of Niger and Aid flow (current US$) of Serbia?
Your answer should be very brief. 1.20e+07. In the year 2007, what is the difference between the Aid flow (current US$) in Low income and Aid flow (current US$) in Moldova?
Provide a short and direct response. 6.58e+08. In the year 2007, what is the difference between the Aid flow (current US$) in Low income and Aid flow (current US$) in Niger?
Provide a short and direct response. 6.45e+08. In the year 2007, what is the difference between the Aid flow (current US$) of Low income and Aid flow (current US$) of Serbia?
Provide a short and direct response. 6.55e+08. In the year 2007, what is the difference between the Aid flow (current US$) of Moldova and Aid flow (current US$) of Niger?
Ensure brevity in your answer.  -1.32e+07. In the year 2007, what is the difference between the Aid flow (current US$) of Moldova and Aid flow (current US$) of Serbia?
Make the answer very short. -3.32e+06. In the year 2007, what is the difference between the Aid flow (current US$) in Niger and Aid flow (current US$) in Serbia?
Make the answer very short. 9.86e+06. In the year 2008, what is the difference between the Aid flow (current US$) in Low income and Aid flow (current US$) in Moldova?
Keep it short and to the point. 7.25e+08. In the year 2008, what is the difference between the Aid flow (current US$) in Low income and Aid flow (current US$) in Niger?
Offer a terse response. 7.12e+08. In the year 2008, what is the difference between the Aid flow (current US$) of Low income and Aid flow (current US$) of Serbia?
Ensure brevity in your answer.  7.24e+08. In the year 2008, what is the difference between the Aid flow (current US$) of Moldova and Aid flow (current US$) of Niger?
Your answer should be very brief. -1.36e+07. In the year 2008, what is the difference between the Aid flow (current US$) of Moldova and Aid flow (current US$) of Serbia?
Offer a very short reply. -7.00e+05. In the year 2008, what is the difference between the Aid flow (current US$) of Niger and Aid flow (current US$) of Serbia?
Provide a short and direct response. 1.29e+07. In the year 2009, what is the difference between the Aid flow (current US$) in Low income and Aid flow (current US$) in Moldova?
Offer a terse response. 7.88e+08. In the year 2009, what is the difference between the Aid flow (current US$) in Low income and Aid flow (current US$) in Niger?
Provide a short and direct response. 7.77e+08. In the year 2009, what is the difference between the Aid flow (current US$) of Low income and Aid flow (current US$) of Serbia?
Your response must be concise. 7.88e+08. In the year 2009, what is the difference between the Aid flow (current US$) in Moldova and Aid flow (current US$) in Niger?
Keep it short and to the point. -1.12e+07. In the year 2009, what is the difference between the Aid flow (current US$) in Moldova and Aid flow (current US$) in Serbia?
Provide a short and direct response. 3.00e+04. In the year 2009, what is the difference between the Aid flow (current US$) in Niger and Aid flow (current US$) in Serbia?
Your answer should be compact. 1.13e+07. In the year 2010, what is the difference between the Aid flow (current US$) in Low income and Aid flow (current US$) in Moldova?
Ensure brevity in your answer.  8.12e+08. In the year 2010, what is the difference between the Aid flow (current US$) of Low income and Aid flow (current US$) of Niger?
Offer a very short reply. 8.02e+08. In the year 2010, what is the difference between the Aid flow (current US$) of Low income and Aid flow (current US$) of Serbia?
Provide a succinct answer. 8.15e+08. In the year 2010, what is the difference between the Aid flow (current US$) of Moldova and Aid flow (current US$) of Niger?
Make the answer very short. -1.03e+07. In the year 2010, what is the difference between the Aid flow (current US$) in Moldova and Aid flow (current US$) in Serbia?
Ensure brevity in your answer.  2.32e+06. In the year 2010, what is the difference between the Aid flow (current US$) of Niger and Aid flow (current US$) of Serbia?
Offer a very short reply. 1.26e+07. In the year 2011, what is the difference between the Aid flow (current US$) of Low income and Aid flow (current US$) of Moldova?
Provide a succinct answer. 8.23e+08. In the year 2011, what is the difference between the Aid flow (current US$) in Low income and Aid flow (current US$) in Niger?
Offer a very short reply. 8.16e+08. In the year 2011, what is the difference between the Aid flow (current US$) in Low income and Aid flow (current US$) in Serbia?
Your response must be concise. 8.22e+08. In the year 2011, what is the difference between the Aid flow (current US$) in Moldova and Aid flow (current US$) in Niger?
Offer a terse response. -6.99e+06. In the year 2011, what is the difference between the Aid flow (current US$) in Moldova and Aid flow (current US$) in Serbia?
Your answer should be compact. -4.40e+05. In the year 2011, what is the difference between the Aid flow (current US$) in Niger and Aid flow (current US$) in Serbia?
Your answer should be compact. 6.55e+06. In the year 2012, what is the difference between the Aid flow (current US$) of Low income and Aid flow (current US$) of Moldova?
Keep it short and to the point. 7.07e+08. In the year 2012, what is the difference between the Aid flow (current US$) of Low income and Aid flow (current US$) of Niger?
Provide a succinct answer. 6.95e+08. In the year 2012, what is the difference between the Aid flow (current US$) in Moldova and Aid flow (current US$) in Niger?
Provide a succinct answer. -1.12e+07. What is the ratio of the Aid flow (current US$) of Low income in 2005 to that in 2006?
Ensure brevity in your answer.  0.92. What is the ratio of the Aid flow (current US$) of Moldova in 2005 to that in 2006?
Provide a short and direct response. 2.2. What is the ratio of the Aid flow (current US$) of Niger in 2005 to that in 2006?
Your answer should be compact. 0.83. What is the ratio of the Aid flow (current US$) in Serbia in 2005 to that in 2006?
Offer a terse response. 9.44. What is the ratio of the Aid flow (current US$) of Low income in 2005 to that in 2007?
Offer a terse response. 0.75. What is the ratio of the Aid flow (current US$) in Moldova in 2005 to that in 2007?
Offer a terse response. 11.25. What is the ratio of the Aid flow (current US$) of Niger in 2005 to that in 2007?
Offer a very short reply. 0.8. What is the ratio of the Aid flow (current US$) in Serbia in 2005 to that in 2007?
Offer a terse response. 2.36. What is the ratio of the Aid flow (current US$) of Low income in 2005 to that in 2008?
Your answer should be very brief. 0.68. What is the ratio of the Aid flow (current US$) of Moldova in 2005 to that in 2008?
Keep it short and to the point. 4.29. What is the ratio of the Aid flow (current US$) in Niger in 2005 to that in 2008?
Ensure brevity in your answer.  0.77. What is the ratio of the Aid flow (current US$) of Serbia in 2005 to that in 2008?
Make the answer very short. 8.81. What is the ratio of the Aid flow (current US$) in Low income in 2005 to that in 2009?
Provide a succinct answer. 0.63. What is the ratio of the Aid flow (current US$) in Moldova in 2005 to that in 2009?
Give a very brief answer. 2.65. What is the ratio of the Aid flow (current US$) of Niger in 2005 to that in 2009?
Make the answer very short. 0.92. What is the ratio of the Aid flow (current US$) of Serbia in 2005 to that in 2009?
Offer a very short reply. 25.87. What is the ratio of the Aid flow (current US$) of Low income in 2005 to that in 2010?
Your answer should be very brief. 0.61. What is the ratio of the Aid flow (current US$) of Moldova in 2005 to that in 2010?
Give a very brief answer. 0.33. What is the ratio of the Aid flow (current US$) in Niger in 2005 to that in 2010?
Ensure brevity in your answer.  0.82. What is the ratio of the Aid flow (current US$) of Serbia in 2005 to that in 2010?
Give a very brief answer. 21.68. What is the ratio of the Aid flow (current US$) in Low income in 2005 to that in 2011?
Make the answer very short. 0.6. What is the ratio of the Aid flow (current US$) of Niger in 2005 to that in 2011?
Make the answer very short. 1.21. What is the ratio of the Aid flow (current US$) of Serbia in 2005 to that in 2011?
Ensure brevity in your answer.  3.58. What is the ratio of the Aid flow (current US$) in Low income in 2005 to that in 2012?
Your answer should be very brief. 0.7. What is the ratio of the Aid flow (current US$) in Moldova in 2005 to that in 2012?
Ensure brevity in your answer.  0.23. What is the ratio of the Aid flow (current US$) of Niger in 2005 to that in 2012?
Provide a succinct answer. 0.7. What is the ratio of the Aid flow (current US$) of Low income in 2006 to that in 2007?
Keep it short and to the point. 0.81. What is the ratio of the Aid flow (current US$) in Moldova in 2006 to that in 2007?
Provide a short and direct response. 5.12. What is the ratio of the Aid flow (current US$) in Niger in 2006 to that in 2007?
Your answer should be compact. 0.97. What is the ratio of the Aid flow (current US$) of Low income in 2006 to that in 2008?
Offer a terse response. 0.74. What is the ratio of the Aid flow (current US$) in Moldova in 2006 to that in 2008?
Make the answer very short. 1.95. What is the ratio of the Aid flow (current US$) of Niger in 2006 to that in 2008?
Ensure brevity in your answer.  0.93. What is the ratio of the Aid flow (current US$) of Serbia in 2006 to that in 2008?
Your response must be concise. 0.93. What is the ratio of the Aid flow (current US$) in Low income in 2006 to that in 2009?
Your answer should be very brief. 0.68. What is the ratio of the Aid flow (current US$) in Moldova in 2006 to that in 2009?
Provide a short and direct response. 1.21. What is the ratio of the Aid flow (current US$) in Niger in 2006 to that in 2009?
Your response must be concise. 1.11. What is the ratio of the Aid flow (current US$) in Serbia in 2006 to that in 2009?
Offer a terse response. 2.74. What is the ratio of the Aid flow (current US$) in Low income in 2006 to that in 2010?
Offer a very short reply. 0.66. What is the ratio of the Aid flow (current US$) in Moldova in 2006 to that in 2010?
Offer a very short reply. 0.15. What is the ratio of the Aid flow (current US$) in Serbia in 2006 to that in 2010?
Provide a short and direct response. 2.3. What is the ratio of the Aid flow (current US$) in Low income in 2006 to that in 2011?
Ensure brevity in your answer.  0.65. What is the ratio of the Aid flow (current US$) of Moldova in 2006 to that in 2011?
Keep it short and to the point. 0.23. What is the ratio of the Aid flow (current US$) of Niger in 2006 to that in 2011?
Ensure brevity in your answer.  1.46. What is the ratio of the Aid flow (current US$) of Serbia in 2006 to that in 2011?
Ensure brevity in your answer.  0.38. What is the ratio of the Aid flow (current US$) of Low income in 2006 to that in 2012?
Offer a terse response. 0.75. What is the ratio of the Aid flow (current US$) in Moldova in 2006 to that in 2012?
Your response must be concise. 0.1. What is the ratio of the Aid flow (current US$) of Niger in 2006 to that in 2012?
Offer a very short reply. 0.85. What is the ratio of the Aid flow (current US$) in Low income in 2007 to that in 2008?
Offer a very short reply. 0.91. What is the ratio of the Aid flow (current US$) in Moldova in 2007 to that in 2008?
Ensure brevity in your answer.  0.38. What is the ratio of the Aid flow (current US$) of Niger in 2007 to that in 2008?
Your response must be concise. 0.96. What is the ratio of the Aid flow (current US$) in Serbia in 2007 to that in 2008?
Offer a very short reply. 3.74. What is the ratio of the Aid flow (current US$) in Low income in 2007 to that in 2009?
Your answer should be compact. 0.83. What is the ratio of the Aid flow (current US$) of Moldova in 2007 to that in 2009?
Provide a succinct answer. 0.24. What is the ratio of the Aid flow (current US$) in Niger in 2007 to that in 2009?
Ensure brevity in your answer.  1.14. What is the ratio of the Aid flow (current US$) in Serbia in 2007 to that in 2009?
Keep it short and to the point. 10.97. What is the ratio of the Aid flow (current US$) of Low income in 2007 to that in 2010?
Offer a very short reply. 0.81. What is the ratio of the Aid flow (current US$) in Moldova in 2007 to that in 2010?
Give a very brief answer. 0.03. What is the ratio of the Aid flow (current US$) of Niger in 2007 to that in 2010?
Offer a very short reply. 1.02. What is the ratio of the Aid flow (current US$) in Serbia in 2007 to that in 2010?
Offer a very short reply. 9.19. What is the ratio of the Aid flow (current US$) in Low income in 2007 to that in 2011?
Provide a short and direct response. 0.8. What is the ratio of the Aid flow (current US$) in Moldova in 2007 to that in 2011?
Keep it short and to the point. 0.04. What is the ratio of the Aid flow (current US$) in Niger in 2007 to that in 2011?
Keep it short and to the point. 1.51. What is the ratio of the Aid flow (current US$) of Serbia in 2007 to that in 2011?
Keep it short and to the point. 1.52. What is the ratio of the Aid flow (current US$) in Low income in 2007 to that in 2012?
Provide a succinct answer. 0.93. What is the ratio of the Aid flow (current US$) in Moldova in 2007 to that in 2012?
Provide a short and direct response. 0.02. What is the ratio of the Aid flow (current US$) in Niger in 2007 to that in 2012?
Ensure brevity in your answer.  0.87. What is the ratio of the Aid flow (current US$) of Low income in 2008 to that in 2009?
Ensure brevity in your answer.  0.92. What is the ratio of the Aid flow (current US$) in Moldova in 2008 to that in 2009?
Give a very brief answer. 0.62. What is the ratio of the Aid flow (current US$) of Niger in 2008 to that in 2009?
Your response must be concise. 1.19. What is the ratio of the Aid flow (current US$) in Serbia in 2008 to that in 2009?
Your response must be concise. 2.94. What is the ratio of the Aid flow (current US$) in Low income in 2008 to that in 2010?
Offer a terse response. 0.89. What is the ratio of the Aid flow (current US$) of Moldova in 2008 to that in 2010?
Your answer should be compact. 0.08. What is the ratio of the Aid flow (current US$) of Niger in 2008 to that in 2010?
Keep it short and to the point. 1.06. What is the ratio of the Aid flow (current US$) in Serbia in 2008 to that in 2010?
Provide a succinct answer. 2.46. What is the ratio of the Aid flow (current US$) in Low income in 2008 to that in 2011?
Keep it short and to the point. 0.88. What is the ratio of the Aid flow (current US$) of Moldova in 2008 to that in 2011?
Keep it short and to the point. 0.12. What is the ratio of the Aid flow (current US$) of Niger in 2008 to that in 2011?
Your answer should be compact. 1.57. What is the ratio of the Aid flow (current US$) in Serbia in 2008 to that in 2011?
Keep it short and to the point. 0.41. What is the ratio of the Aid flow (current US$) of Low income in 2008 to that in 2012?
Offer a terse response. 1.02. What is the ratio of the Aid flow (current US$) of Moldova in 2008 to that in 2012?
Provide a succinct answer. 0.05. What is the ratio of the Aid flow (current US$) of Niger in 2008 to that in 2012?
Provide a short and direct response. 0.91. What is the ratio of the Aid flow (current US$) in Low income in 2009 to that in 2010?
Provide a short and direct response. 0.97. What is the ratio of the Aid flow (current US$) of Moldova in 2009 to that in 2010?
Keep it short and to the point. 0.13. What is the ratio of the Aid flow (current US$) of Niger in 2009 to that in 2010?
Keep it short and to the point. 0.89. What is the ratio of the Aid flow (current US$) of Serbia in 2009 to that in 2010?
Your answer should be very brief. 0.84. What is the ratio of the Aid flow (current US$) in Low income in 2009 to that in 2011?
Your answer should be very brief. 0.96. What is the ratio of the Aid flow (current US$) of Moldova in 2009 to that in 2011?
Your response must be concise. 0.19. What is the ratio of the Aid flow (current US$) of Niger in 2009 to that in 2011?
Provide a succinct answer. 1.32. What is the ratio of the Aid flow (current US$) of Serbia in 2009 to that in 2011?
Offer a terse response. 0.14. What is the ratio of the Aid flow (current US$) in Low income in 2009 to that in 2012?
Provide a short and direct response. 1.11. What is the ratio of the Aid flow (current US$) of Moldova in 2009 to that in 2012?
Your answer should be very brief. 0.09. What is the ratio of the Aid flow (current US$) of Niger in 2009 to that in 2012?
Give a very brief answer. 0.76. What is the ratio of the Aid flow (current US$) of Low income in 2010 to that in 2011?
Give a very brief answer. 0.99. What is the ratio of the Aid flow (current US$) of Moldova in 2010 to that in 2011?
Give a very brief answer. 1.49. What is the ratio of the Aid flow (current US$) of Niger in 2010 to that in 2011?
Provide a short and direct response. 1.47. What is the ratio of the Aid flow (current US$) of Serbia in 2010 to that in 2011?
Keep it short and to the point. 0.17. What is the ratio of the Aid flow (current US$) of Low income in 2010 to that in 2012?
Offer a very short reply. 1.15. What is the ratio of the Aid flow (current US$) of Moldova in 2010 to that in 2012?
Ensure brevity in your answer.  0.68. What is the ratio of the Aid flow (current US$) of Niger in 2010 to that in 2012?
Your response must be concise. 0.85. What is the ratio of the Aid flow (current US$) of Low income in 2011 to that in 2012?
Your response must be concise. 1.16. What is the ratio of the Aid flow (current US$) of Moldova in 2011 to that in 2012?
Make the answer very short. 0.45. What is the ratio of the Aid flow (current US$) of Niger in 2011 to that in 2012?
Keep it short and to the point. 0.58. What is the difference between the highest and the second highest Aid flow (current US$) of Low income?
Ensure brevity in your answer.  9.54e+06. What is the difference between the highest and the second highest Aid flow (current US$) of Moldova?
Provide a short and direct response. 1.28e+06. What is the difference between the highest and the second highest Aid flow (current US$) in Niger?
Keep it short and to the point. 1.39e+06. What is the difference between the highest and the second highest Aid flow (current US$) of Serbia?
Give a very brief answer. 4.62e+06. What is the difference between the highest and the lowest Aid flow (current US$) of Low income?
Your response must be concise. 3.30e+08. What is the difference between the highest and the lowest Aid flow (current US$) in Moldova?
Keep it short and to the point. 3.89e+06. What is the difference between the highest and the lowest Aid flow (current US$) of Niger?
Your answer should be compact. 6.39e+06. What is the difference between the highest and the lowest Aid flow (current US$) of Serbia?
Your response must be concise. 8.02e+06. 